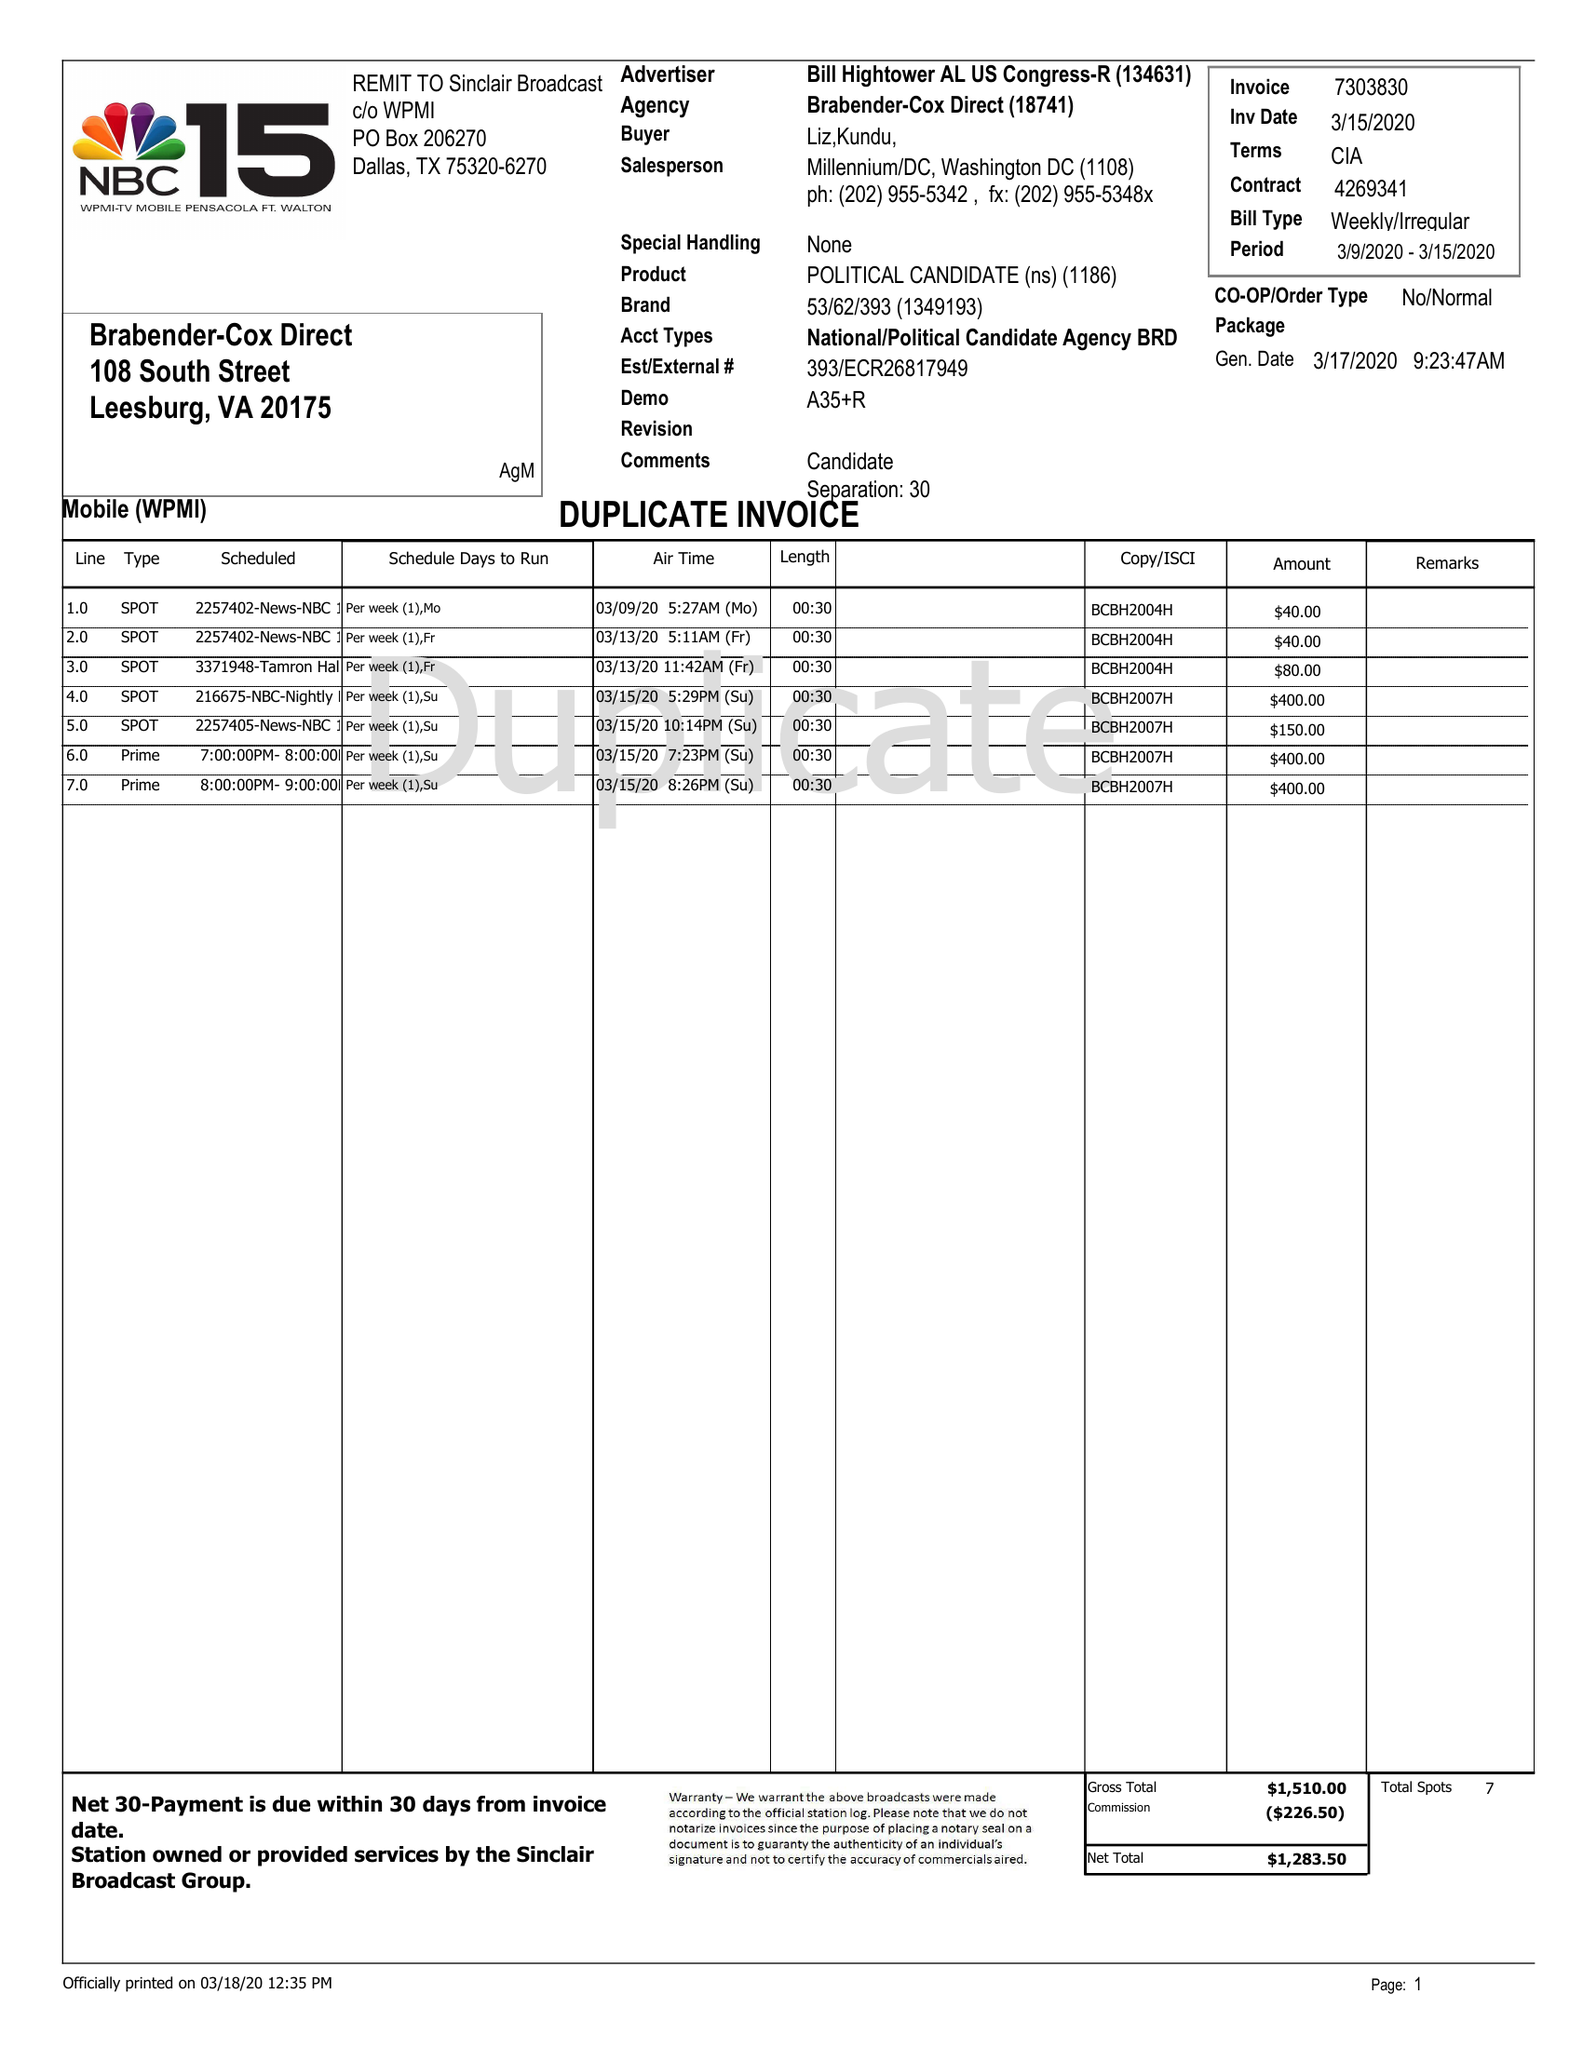What is the value for the contract_num?
Answer the question using a single word or phrase. 4269341 